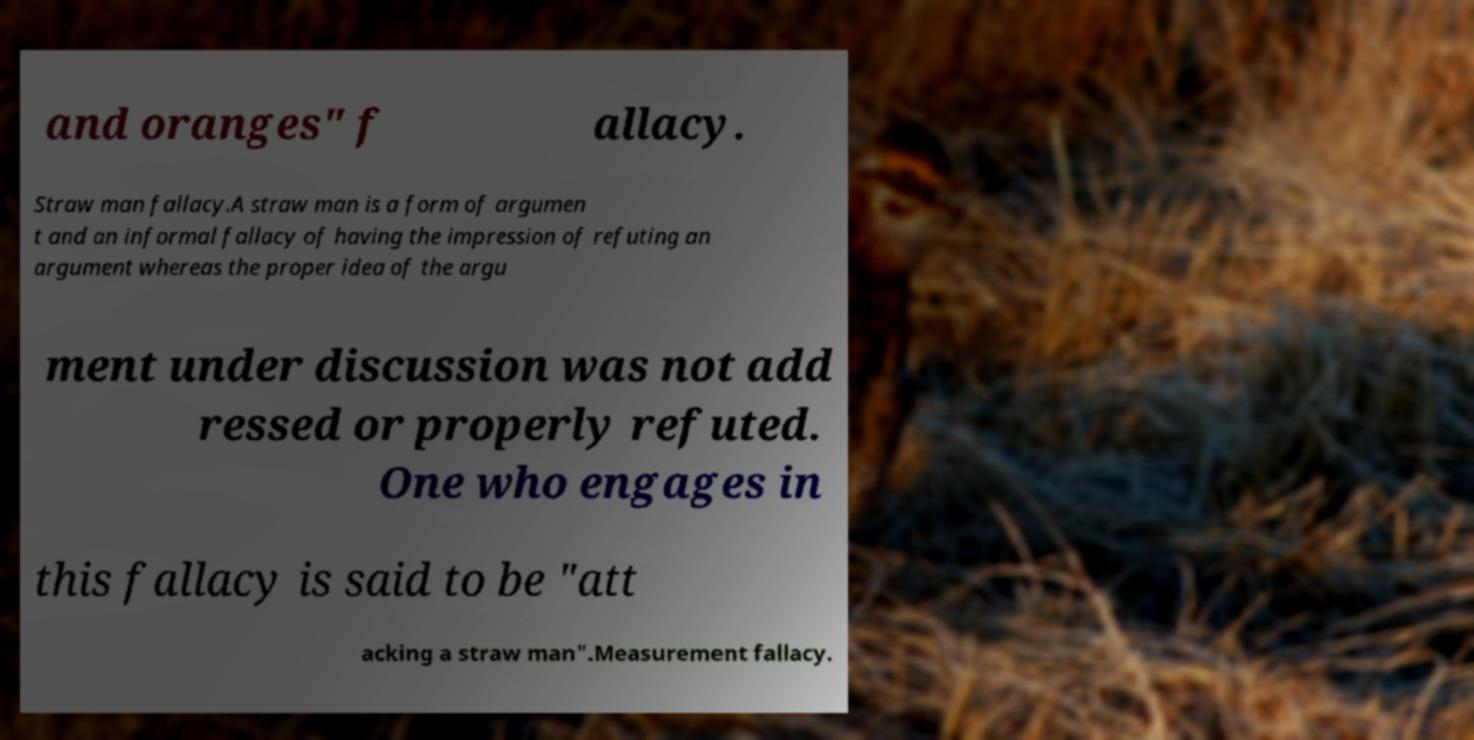What messages or text are displayed in this image? I need them in a readable, typed format. and oranges" f allacy. Straw man fallacy.A straw man is a form of argumen t and an informal fallacy of having the impression of refuting an argument whereas the proper idea of the argu ment under discussion was not add ressed or properly refuted. One who engages in this fallacy is said to be "att acking a straw man".Measurement fallacy. 